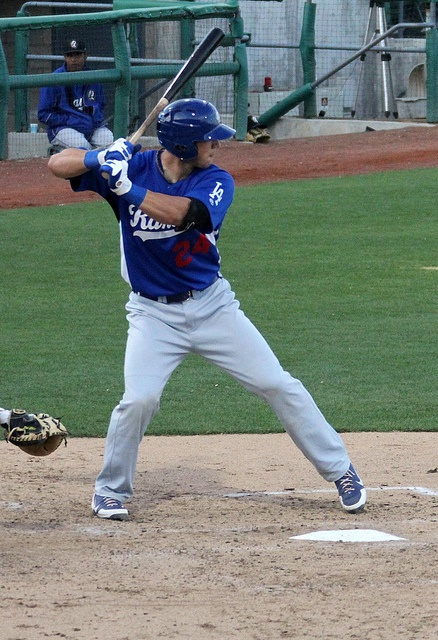Describe the objects in this image and their specific colors. I can see people in black, lightblue, navy, and darkgray tones, people in black, navy, and darkgray tones, baseball glove in black, gray, beige, and darkgray tones, baseball bat in black, gray, and darkgray tones, and baseball glove in black and gray tones in this image. 